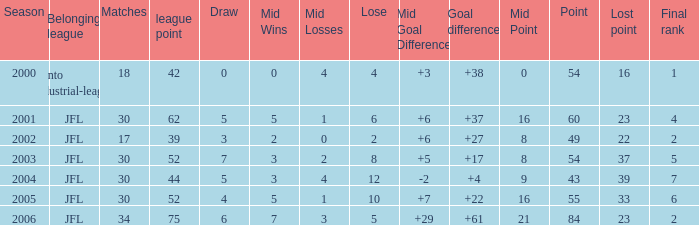What is the mean final position for loe exceeding 10 and score below 43? None. 